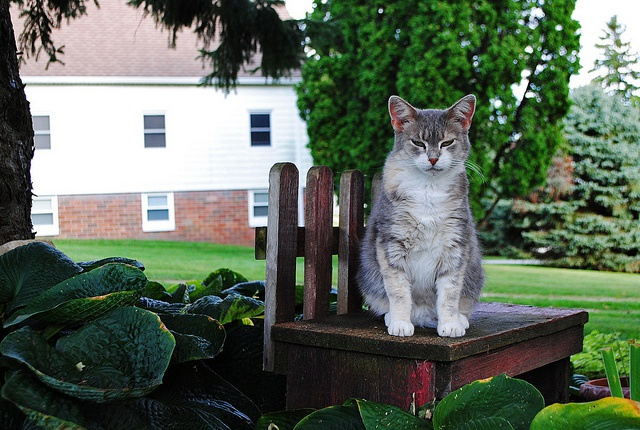Describe the objects in this image and their specific colors. I can see bench in black, maroon, and gray tones, cat in black, darkgray, gray, and lightgray tones, and potted plant in black, darkgreen, gray, and green tones in this image. 